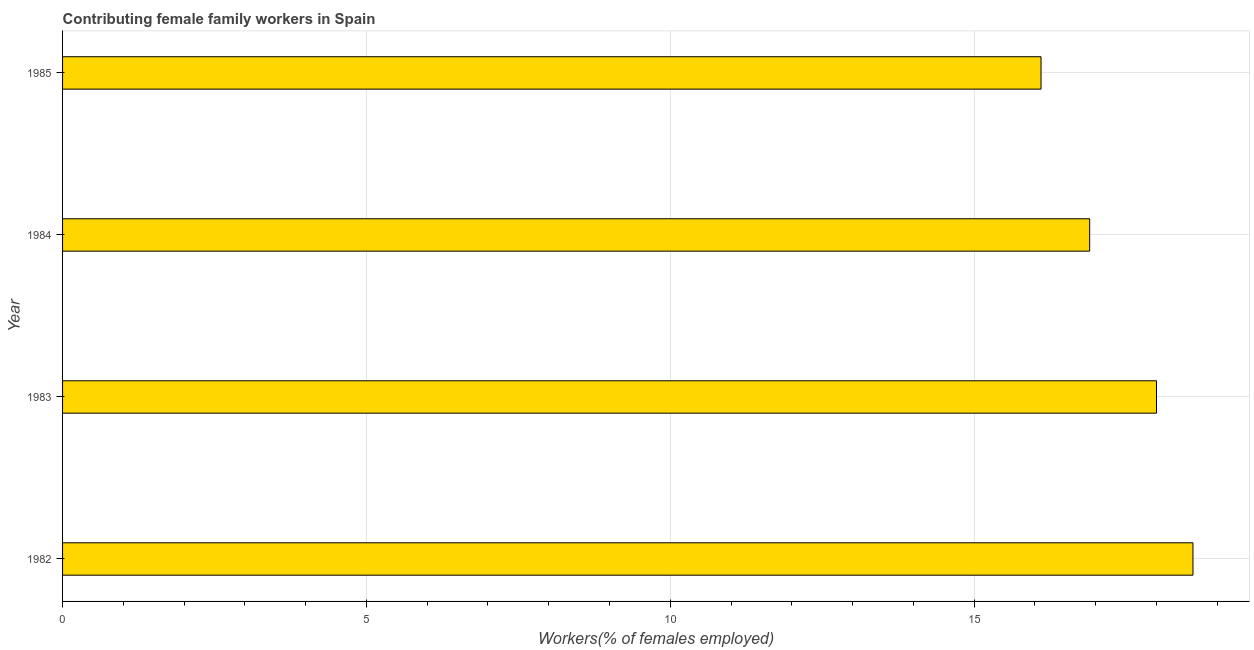Does the graph contain any zero values?
Provide a succinct answer. No. What is the title of the graph?
Your answer should be compact. Contributing female family workers in Spain. What is the label or title of the X-axis?
Ensure brevity in your answer.  Workers(% of females employed). What is the contributing female family workers in 1985?
Your response must be concise. 16.1. Across all years, what is the maximum contributing female family workers?
Offer a terse response. 18.6. Across all years, what is the minimum contributing female family workers?
Your response must be concise. 16.1. In which year was the contributing female family workers minimum?
Provide a short and direct response. 1985. What is the sum of the contributing female family workers?
Give a very brief answer. 69.6. What is the difference between the contributing female family workers in 1982 and 1983?
Make the answer very short. 0.6. What is the average contributing female family workers per year?
Offer a terse response. 17.4. What is the median contributing female family workers?
Offer a very short reply. 17.45. In how many years, is the contributing female family workers greater than 9 %?
Provide a short and direct response. 4. Do a majority of the years between 1984 and 1985 (inclusive) have contributing female family workers greater than 8 %?
Provide a short and direct response. Yes. What is the ratio of the contributing female family workers in 1983 to that in 1985?
Your answer should be compact. 1.12. Is the contributing female family workers in 1982 less than that in 1983?
Provide a succinct answer. No. What is the difference between the highest and the second highest contributing female family workers?
Keep it short and to the point. 0.6. How many years are there in the graph?
Offer a terse response. 4. What is the difference between two consecutive major ticks on the X-axis?
Offer a terse response. 5. What is the Workers(% of females employed) of 1982?
Ensure brevity in your answer.  18.6. What is the Workers(% of females employed) of 1983?
Make the answer very short. 18. What is the Workers(% of females employed) in 1984?
Your answer should be compact. 16.9. What is the Workers(% of females employed) of 1985?
Offer a terse response. 16.1. What is the difference between the Workers(% of females employed) in 1982 and 1983?
Provide a short and direct response. 0.6. What is the difference between the Workers(% of females employed) in 1982 and 1984?
Make the answer very short. 1.7. What is the difference between the Workers(% of females employed) in 1982 and 1985?
Give a very brief answer. 2.5. What is the difference between the Workers(% of females employed) in 1983 and 1984?
Make the answer very short. 1.1. What is the ratio of the Workers(% of females employed) in 1982 to that in 1983?
Offer a terse response. 1.03. What is the ratio of the Workers(% of females employed) in 1982 to that in 1984?
Your answer should be compact. 1.1. What is the ratio of the Workers(% of females employed) in 1982 to that in 1985?
Provide a short and direct response. 1.16. What is the ratio of the Workers(% of females employed) in 1983 to that in 1984?
Ensure brevity in your answer.  1.06. What is the ratio of the Workers(% of females employed) in 1983 to that in 1985?
Offer a very short reply. 1.12. 